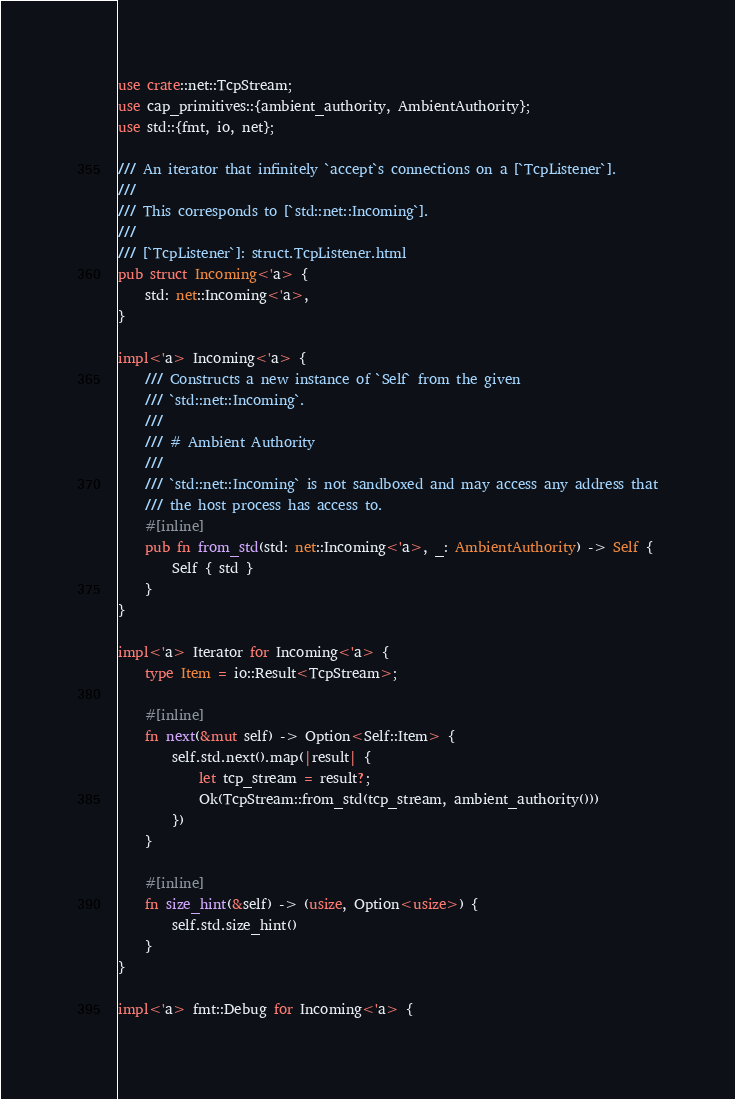Convert code to text. <code><loc_0><loc_0><loc_500><loc_500><_Rust_>use crate::net::TcpStream;
use cap_primitives::{ambient_authority, AmbientAuthority};
use std::{fmt, io, net};

/// An iterator that infinitely `accept`s connections on a [`TcpListener`].
///
/// This corresponds to [`std::net::Incoming`].
///
/// [`TcpListener`]: struct.TcpListener.html
pub struct Incoming<'a> {
    std: net::Incoming<'a>,
}

impl<'a> Incoming<'a> {
    /// Constructs a new instance of `Self` from the given
    /// `std::net::Incoming`.
    ///
    /// # Ambient Authority
    ///
    /// `std::net::Incoming` is not sandboxed and may access any address that
    /// the host process has access to.
    #[inline]
    pub fn from_std(std: net::Incoming<'a>, _: AmbientAuthority) -> Self {
        Self { std }
    }
}

impl<'a> Iterator for Incoming<'a> {
    type Item = io::Result<TcpStream>;

    #[inline]
    fn next(&mut self) -> Option<Self::Item> {
        self.std.next().map(|result| {
            let tcp_stream = result?;
            Ok(TcpStream::from_std(tcp_stream, ambient_authority()))
        })
    }

    #[inline]
    fn size_hint(&self) -> (usize, Option<usize>) {
        self.std.size_hint()
    }
}

impl<'a> fmt::Debug for Incoming<'a> {</code> 